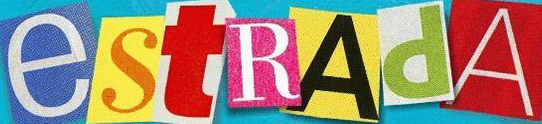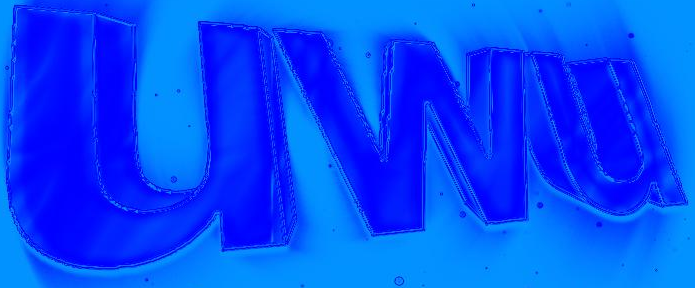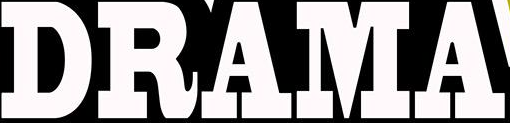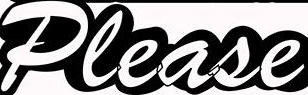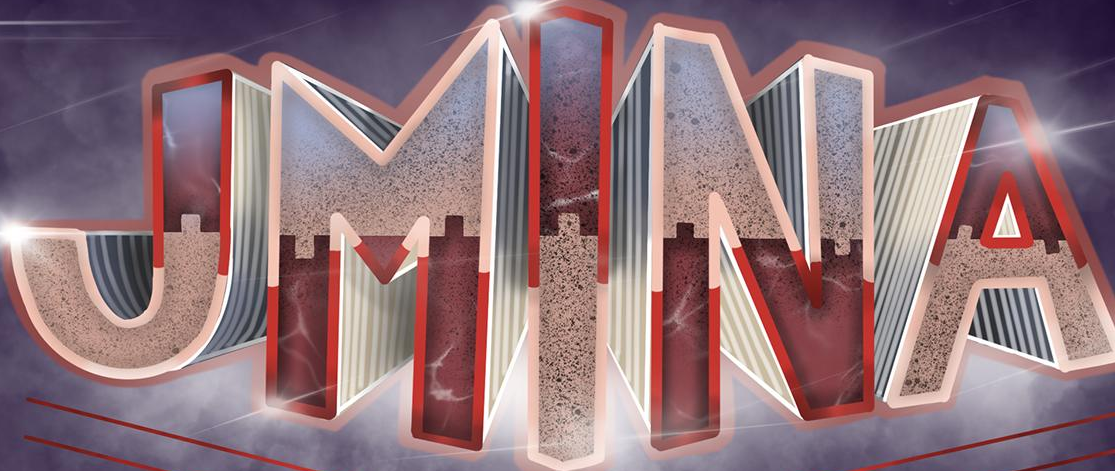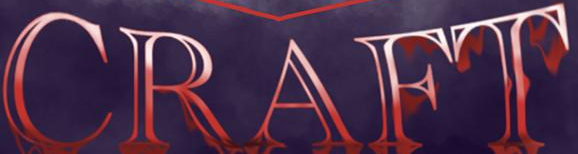Read the text content from these images in order, separated by a semicolon. estRAdA; uwu; DRAMA; Please; JMINA; CRAFT 